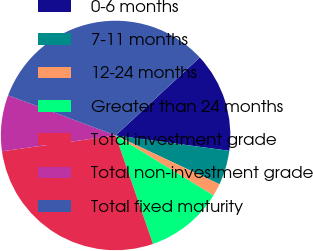<chart> <loc_0><loc_0><loc_500><loc_500><pie_chart><fcel>0-6 months<fcel>7-11 months<fcel>12-24 months<fcel>Greater than 24 months<fcel>Total investment grade<fcel>Total non-investment grade<fcel>Total fixed maturity<nl><fcel>14.03%<fcel>4.84%<fcel>1.77%<fcel>10.97%<fcel>28.07%<fcel>7.9%<fcel>32.41%<nl></chart> 